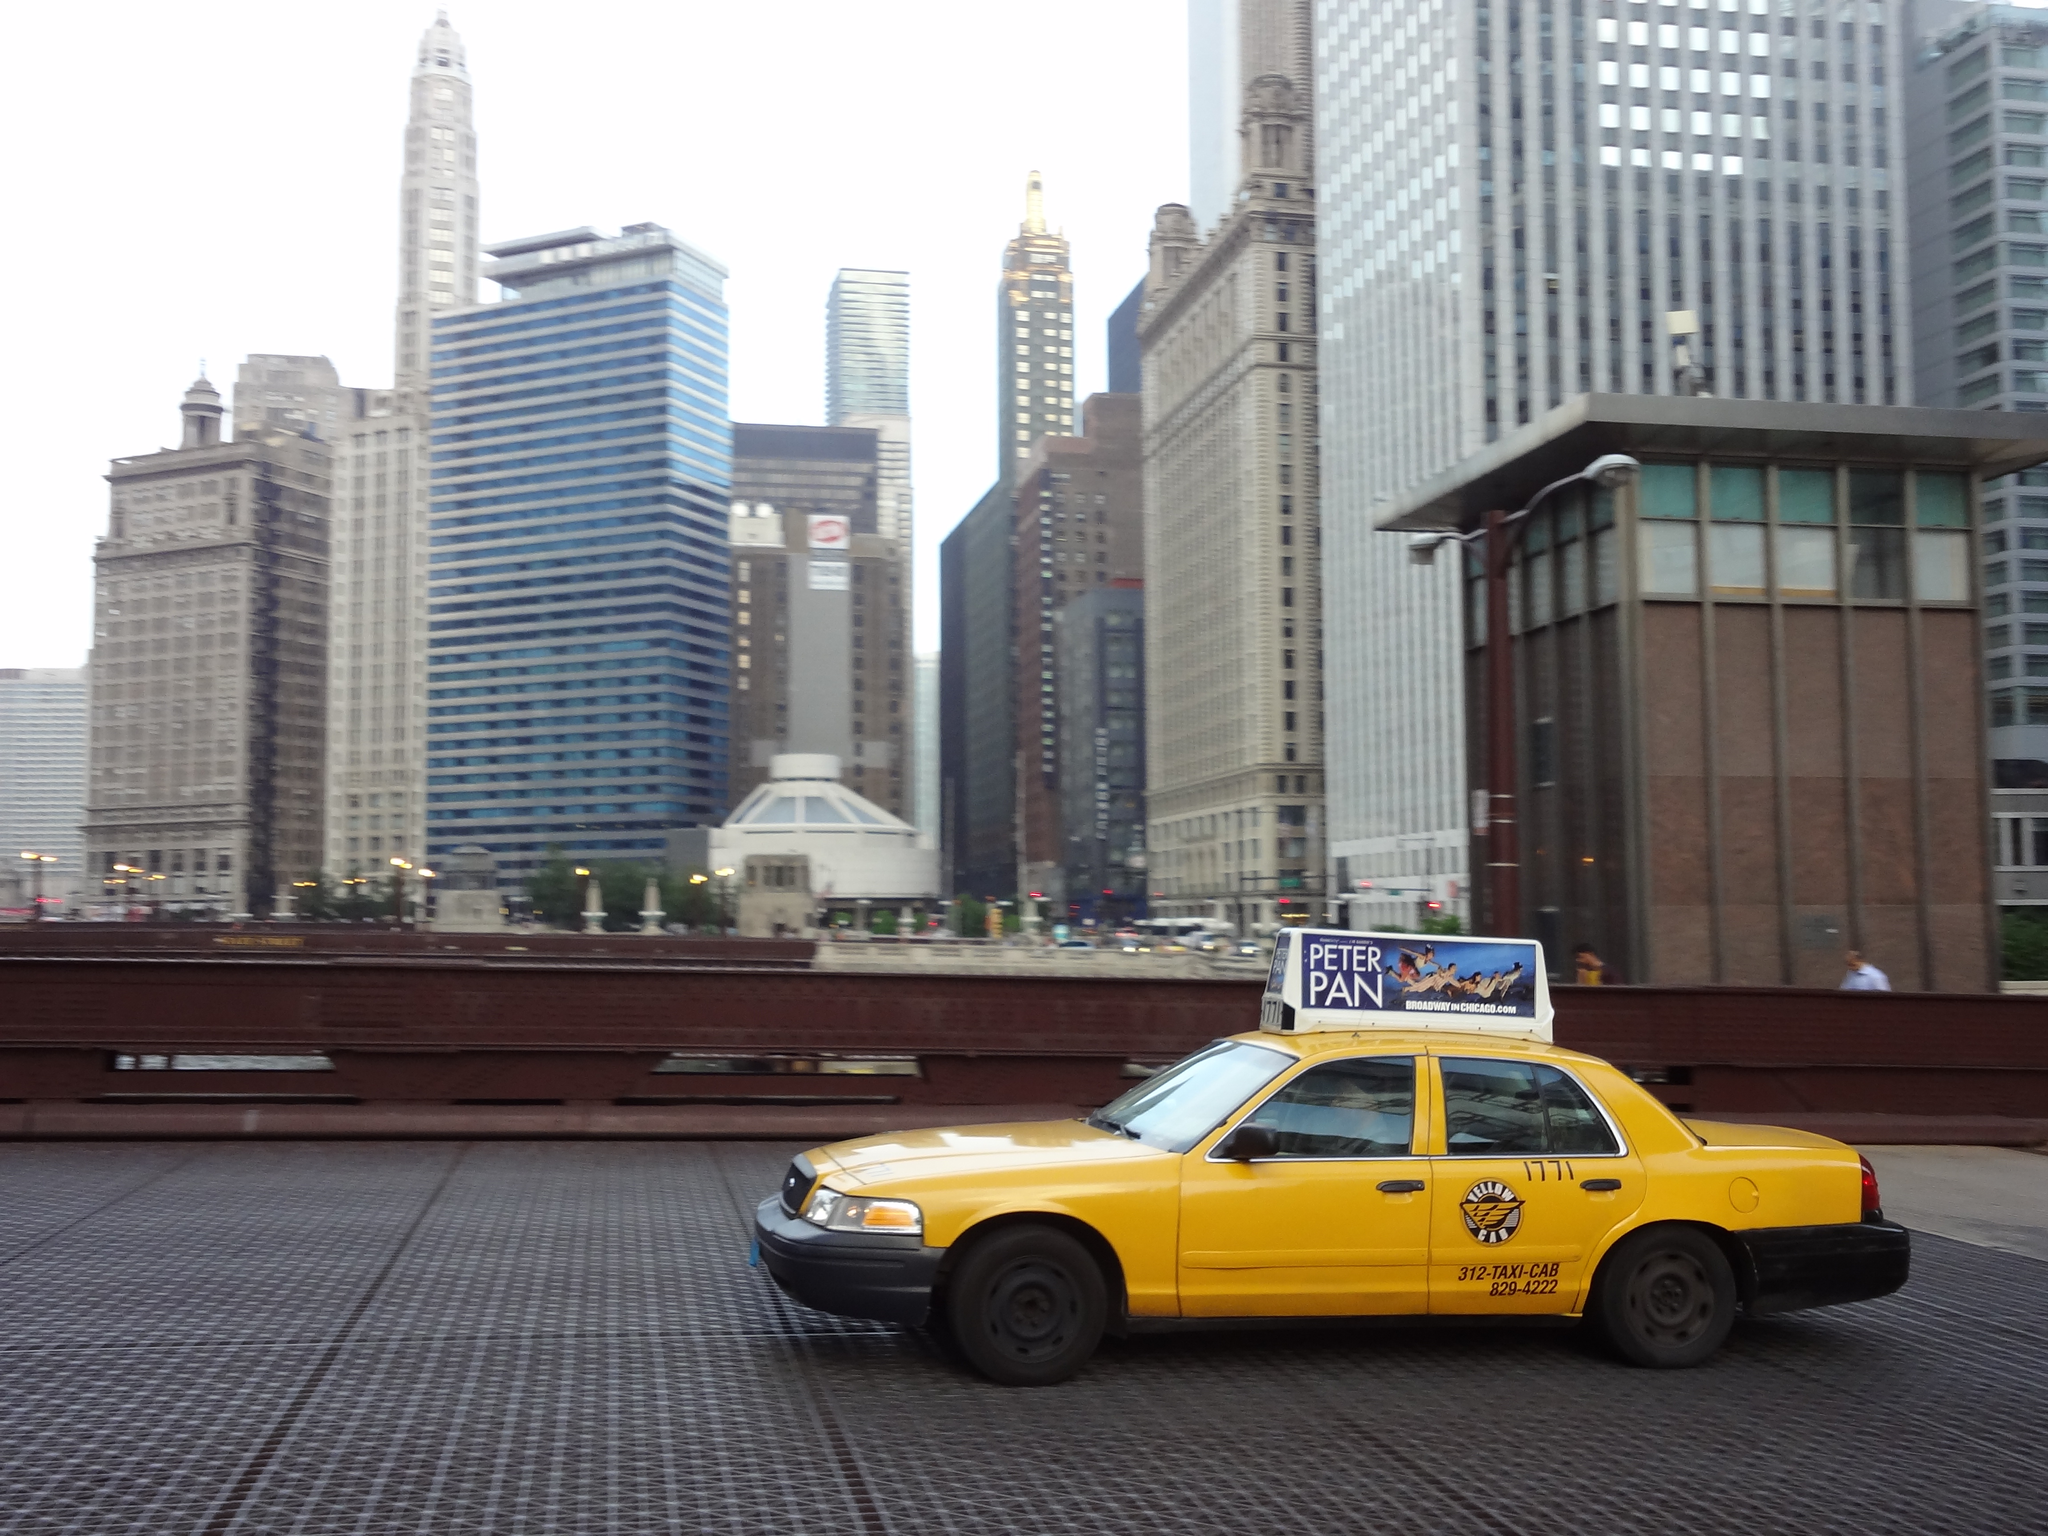<image>
Write a terse but informative summary of the picture. A taxi travels down a street with a Peter Pan advertisement mounted on top of it. 